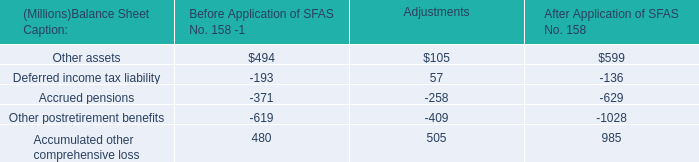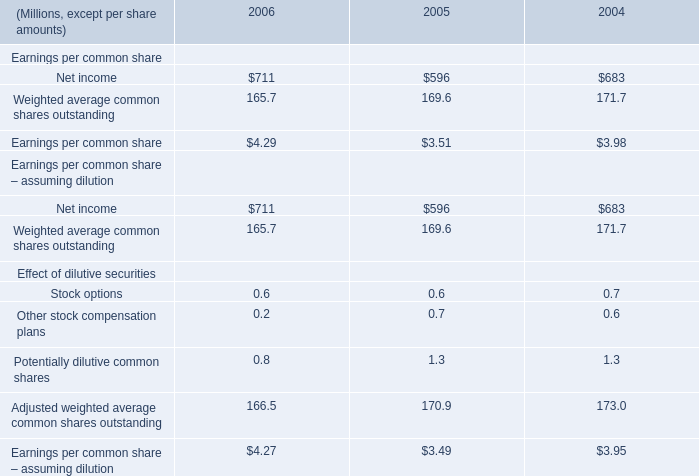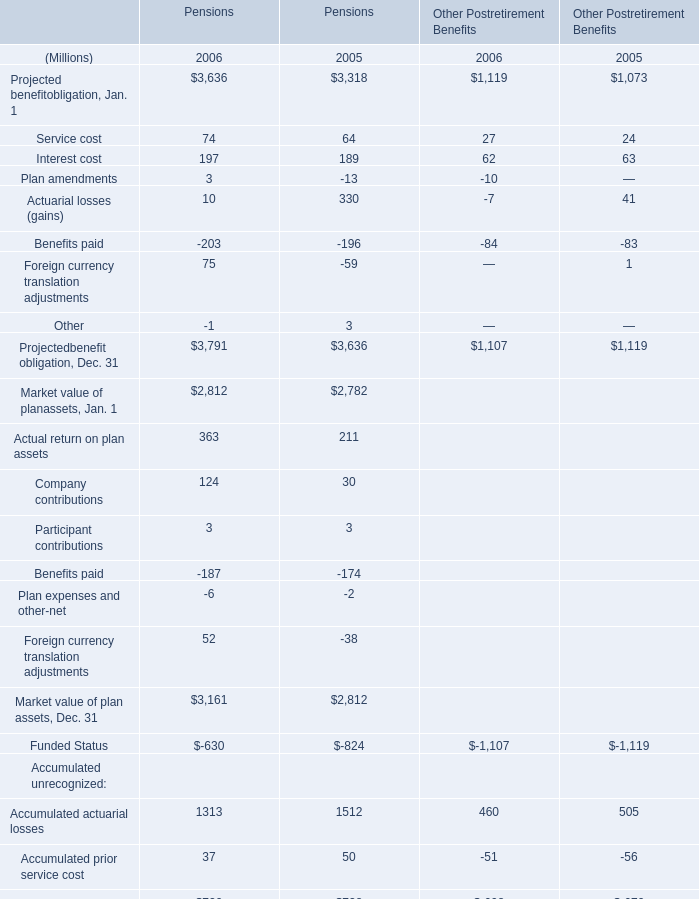What's the average of Projected benefit obligation for pensions in 2006? (in million) 
Computations: ((((((((3636 + 74) + 197) + 3) + 10) - 203) + 75) - 1) / 8)
Answer: 473.875. 